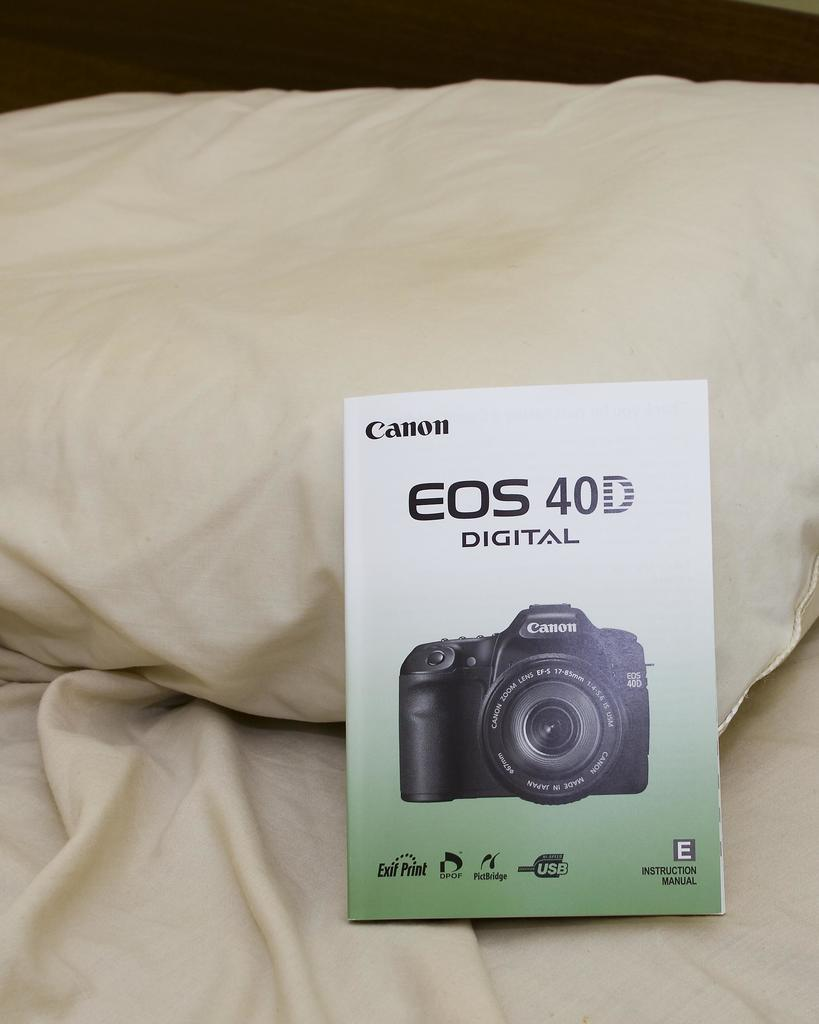What object can be seen in the image? There is a book in the image. Where is the book located? The book is on a bed. What can be read on the book? The book has the words "EOS 40D Digital" written on it. What is depicted on the book? There is a camera picture on the book. What type of zinc is present in the image? There is no zinc present in the image. What office supplies can be seen in the image? The image does not show any office supplies. 